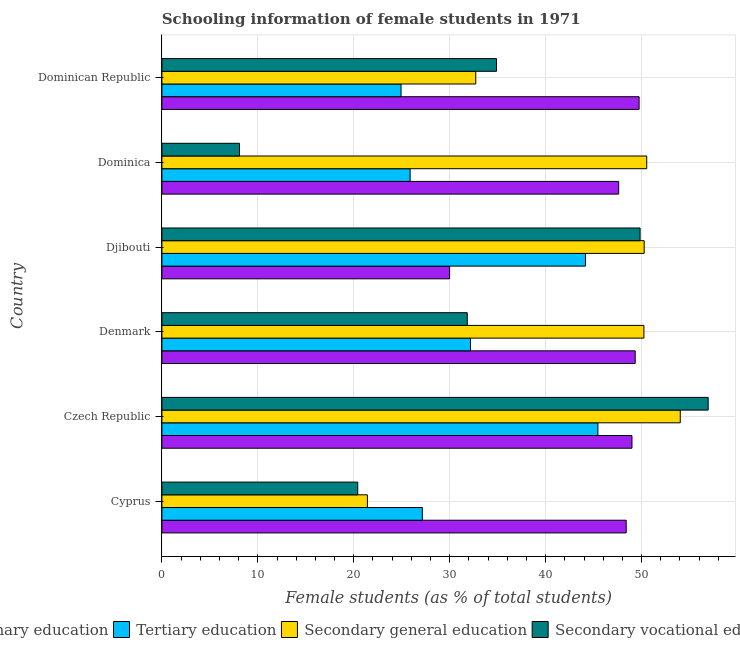How many different coloured bars are there?
Your answer should be compact. 4. Are the number of bars per tick equal to the number of legend labels?
Ensure brevity in your answer.  Yes. What is the label of the 4th group of bars from the top?
Your response must be concise. Denmark. In how many cases, is the number of bars for a given country not equal to the number of legend labels?
Keep it short and to the point. 0. What is the percentage of female students in secondary education in Dominica?
Your response must be concise. 50.54. Across all countries, what is the maximum percentage of female students in secondary vocational education?
Provide a short and direct response. 56.94. Across all countries, what is the minimum percentage of female students in secondary education?
Your response must be concise. 21.42. In which country was the percentage of female students in primary education maximum?
Provide a succinct answer. Dominican Republic. In which country was the percentage of female students in tertiary education minimum?
Provide a short and direct response. Dominican Republic. What is the total percentage of female students in secondary vocational education in the graph?
Ensure brevity in your answer.  202. What is the difference between the percentage of female students in secondary vocational education in Czech Republic and that in Djibouti?
Provide a short and direct response. 7.1. What is the difference between the percentage of female students in secondary vocational education in Cyprus and the percentage of female students in tertiary education in Denmark?
Give a very brief answer. -11.76. What is the average percentage of female students in primary education per country?
Your response must be concise. 45.68. What is the difference between the percentage of female students in tertiary education and percentage of female students in secondary vocational education in Dominica?
Your answer should be compact. 17.79. In how many countries, is the percentage of female students in tertiary education greater than 30 %?
Give a very brief answer. 3. What is the ratio of the percentage of female students in secondary vocational education in Denmark to that in Djibouti?
Offer a very short reply. 0.64. Is the difference between the percentage of female students in secondary education in Czech Republic and Dominica greater than the difference between the percentage of female students in primary education in Czech Republic and Dominica?
Your response must be concise. Yes. What is the difference between the highest and the second highest percentage of female students in tertiary education?
Your answer should be very brief. 1.3. What is the difference between the highest and the lowest percentage of female students in secondary vocational education?
Your answer should be very brief. 48.86. Is it the case that in every country, the sum of the percentage of female students in tertiary education and percentage of female students in secondary vocational education is greater than the sum of percentage of female students in primary education and percentage of female students in secondary education?
Provide a succinct answer. No. What does the 1st bar from the top in Czech Republic represents?
Your answer should be compact. Secondary vocational education. What does the 3rd bar from the bottom in Djibouti represents?
Keep it short and to the point. Secondary general education. Is it the case that in every country, the sum of the percentage of female students in primary education and percentage of female students in tertiary education is greater than the percentage of female students in secondary education?
Keep it short and to the point. Yes. What is the difference between two consecutive major ticks on the X-axis?
Keep it short and to the point. 10. Are the values on the major ticks of X-axis written in scientific E-notation?
Keep it short and to the point. No. Does the graph contain any zero values?
Provide a succinct answer. No. Does the graph contain grids?
Offer a terse response. Yes. How many legend labels are there?
Give a very brief answer. 4. What is the title of the graph?
Your response must be concise. Schooling information of female students in 1971. Does "Agriculture" appear as one of the legend labels in the graph?
Make the answer very short. No. What is the label or title of the X-axis?
Offer a terse response. Female students (as % of total students). What is the label or title of the Y-axis?
Your answer should be very brief. Country. What is the Female students (as % of total students) in Primary education in Cyprus?
Provide a short and direct response. 48.4. What is the Female students (as % of total students) in Tertiary education in Cyprus?
Ensure brevity in your answer.  27.15. What is the Female students (as % of total students) in Secondary general education in Cyprus?
Give a very brief answer. 21.42. What is the Female students (as % of total students) of Secondary vocational education in Cyprus?
Your response must be concise. 20.41. What is the Female students (as % of total students) in Primary education in Czech Republic?
Your answer should be compact. 49. What is the Female students (as % of total students) of Tertiary education in Czech Republic?
Your answer should be compact. 45.45. What is the Female students (as % of total students) in Secondary general education in Czech Republic?
Your answer should be very brief. 54.03. What is the Female students (as % of total students) of Secondary vocational education in Czech Republic?
Offer a terse response. 56.94. What is the Female students (as % of total students) in Primary education in Denmark?
Offer a terse response. 49.33. What is the Female students (as % of total students) in Tertiary education in Denmark?
Your response must be concise. 32.17. What is the Female students (as % of total students) in Secondary general education in Denmark?
Ensure brevity in your answer.  50.24. What is the Female students (as % of total students) in Secondary vocational education in Denmark?
Your answer should be compact. 31.83. What is the Female students (as % of total students) of Primary education in Djibouti?
Your response must be concise. 29.99. What is the Female students (as % of total students) of Tertiary education in Djibouti?
Provide a short and direct response. 44.15. What is the Female students (as % of total students) of Secondary general education in Djibouti?
Make the answer very short. 50.27. What is the Female students (as % of total students) in Secondary vocational education in Djibouti?
Keep it short and to the point. 49.85. What is the Female students (as % of total students) of Primary education in Dominica?
Your answer should be very brief. 47.61. What is the Female students (as % of total students) in Tertiary education in Dominica?
Offer a terse response. 25.87. What is the Female students (as % of total students) in Secondary general education in Dominica?
Your response must be concise. 50.54. What is the Female students (as % of total students) of Secondary vocational education in Dominica?
Offer a very short reply. 8.09. What is the Female students (as % of total students) in Primary education in Dominican Republic?
Keep it short and to the point. 49.74. What is the Female students (as % of total students) of Tertiary education in Dominican Republic?
Provide a succinct answer. 24.93. What is the Female students (as % of total students) of Secondary general education in Dominican Republic?
Offer a terse response. 32.72. What is the Female students (as % of total students) in Secondary vocational education in Dominican Republic?
Give a very brief answer. 34.88. Across all countries, what is the maximum Female students (as % of total students) of Primary education?
Provide a succinct answer. 49.74. Across all countries, what is the maximum Female students (as % of total students) of Tertiary education?
Your answer should be compact. 45.45. Across all countries, what is the maximum Female students (as % of total students) of Secondary general education?
Provide a short and direct response. 54.03. Across all countries, what is the maximum Female students (as % of total students) in Secondary vocational education?
Provide a succinct answer. 56.94. Across all countries, what is the minimum Female students (as % of total students) of Primary education?
Ensure brevity in your answer.  29.99. Across all countries, what is the minimum Female students (as % of total students) in Tertiary education?
Make the answer very short. 24.93. Across all countries, what is the minimum Female students (as % of total students) in Secondary general education?
Your answer should be very brief. 21.42. Across all countries, what is the minimum Female students (as % of total students) of Secondary vocational education?
Make the answer very short. 8.09. What is the total Female students (as % of total students) of Primary education in the graph?
Your answer should be compact. 274.08. What is the total Female students (as % of total students) in Tertiary education in the graph?
Keep it short and to the point. 199.72. What is the total Female students (as % of total students) in Secondary general education in the graph?
Give a very brief answer. 259.22. What is the total Female students (as % of total students) of Secondary vocational education in the graph?
Give a very brief answer. 202. What is the difference between the Female students (as % of total students) in Primary education in Cyprus and that in Czech Republic?
Your answer should be very brief. -0.6. What is the difference between the Female students (as % of total students) of Tertiary education in Cyprus and that in Czech Republic?
Ensure brevity in your answer.  -18.3. What is the difference between the Female students (as % of total students) in Secondary general education in Cyprus and that in Czech Republic?
Offer a very short reply. -32.61. What is the difference between the Female students (as % of total students) in Secondary vocational education in Cyprus and that in Czech Republic?
Give a very brief answer. -36.53. What is the difference between the Female students (as % of total students) of Primary education in Cyprus and that in Denmark?
Your answer should be compact. -0.94. What is the difference between the Female students (as % of total students) of Tertiary education in Cyprus and that in Denmark?
Make the answer very short. -5.02. What is the difference between the Female students (as % of total students) in Secondary general education in Cyprus and that in Denmark?
Give a very brief answer. -28.82. What is the difference between the Female students (as % of total students) of Secondary vocational education in Cyprus and that in Denmark?
Offer a terse response. -11.42. What is the difference between the Female students (as % of total students) of Primary education in Cyprus and that in Djibouti?
Provide a short and direct response. 18.41. What is the difference between the Female students (as % of total students) in Tertiary education in Cyprus and that in Djibouti?
Make the answer very short. -17. What is the difference between the Female students (as % of total students) of Secondary general education in Cyprus and that in Djibouti?
Keep it short and to the point. -28.85. What is the difference between the Female students (as % of total students) of Secondary vocational education in Cyprus and that in Djibouti?
Provide a short and direct response. -29.43. What is the difference between the Female students (as % of total students) in Primary education in Cyprus and that in Dominica?
Keep it short and to the point. 0.78. What is the difference between the Female students (as % of total students) in Tertiary education in Cyprus and that in Dominica?
Your answer should be compact. 1.28. What is the difference between the Female students (as % of total students) of Secondary general education in Cyprus and that in Dominica?
Keep it short and to the point. -29.12. What is the difference between the Female students (as % of total students) in Secondary vocational education in Cyprus and that in Dominica?
Offer a very short reply. 12.33. What is the difference between the Female students (as % of total students) in Primary education in Cyprus and that in Dominican Republic?
Your answer should be compact. -1.35. What is the difference between the Female students (as % of total students) of Tertiary education in Cyprus and that in Dominican Republic?
Keep it short and to the point. 2.22. What is the difference between the Female students (as % of total students) of Secondary general education in Cyprus and that in Dominican Republic?
Offer a terse response. -11.3. What is the difference between the Female students (as % of total students) in Secondary vocational education in Cyprus and that in Dominican Republic?
Provide a short and direct response. -14.46. What is the difference between the Female students (as % of total students) of Primary education in Czech Republic and that in Denmark?
Provide a succinct answer. -0.33. What is the difference between the Female students (as % of total students) in Tertiary education in Czech Republic and that in Denmark?
Provide a short and direct response. 13.28. What is the difference between the Female students (as % of total students) in Secondary general education in Czech Republic and that in Denmark?
Offer a very short reply. 3.79. What is the difference between the Female students (as % of total students) in Secondary vocational education in Czech Republic and that in Denmark?
Provide a succinct answer. 25.11. What is the difference between the Female students (as % of total students) of Primary education in Czech Republic and that in Djibouti?
Give a very brief answer. 19.01. What is the difference between the Female students (as % of total students) in Tertiary education in Czech Republic and that in Djibouti?
Keep it short and to the point. 1.3. What is the difference between the Female students (as % of total students) in Secondary general education in Czech Republic and that in Djibouti?
Offer a terse response. 3.76. What is the difference between the Female students (as % of total students) in Secondary vocational education in Czech Republic and that in Djibouti?
Offer a very short reply. 7.1. What is the difference between the Female students (as % of total students) of Primary education in Czech Republic and that in Dominica?
Offer a terse response. 1.39. What is the difference between the Female students (as % of total students) of Tertiary education in Czech Republic and that in Dominica?
Provide a short and direct response. 19.58. What is the difference between the Female students (as % of total students) of Secondary general education in Czech Republic and that in Dominica?
Give a very brief answer. 3.5. What is the difference between the Female students (as % of total students) of Secondary vocational education in Czech Republic and that in Dominica?
Ensure brevity in your answer.  48.85. What is the difference between the Female students (as % of total students) in Primary education in Czech Republic and that in Dominican Republic?
Provide a short and direct response. -0.74. What is the difference between the Female students (as % of total students) in Tertiary education in Czech Republic and that in Dominican Republic?
Keep it short and to the point. 20.52. What is the difference between the Female students (as % of total students) of Secondary general education in Czech Republic and that in Dominican Republic?
Your response must be concise. 21.32. What is the difference between the Female students (as % of total students) of Secondary vocational education in Czech Republic and that in Dominican Republic?
Your answer should be compact. 22.06. What is the difference between the Female students (as % of total students) of Primary education in Denmark and that in Djibouti?
Ensure brevity in your answer.  19.34. What is the difference between the Female students (as % of total students) in Tertiary education in Denmark and that in Djibouti?
Your answer should be compact. -11.98. What is the difference between the Female students (as % of total students) of Secondary general education in Denmark and that in Djibouti?
Provide a short and direct response. -0.03. What is the difference between the Female students (as % of total students) of Secondary vocational education in Denmark and that in Djibouti?
Provide a short and direct response. -18.02. What is the difference between the Female students (as % of total students) in Primary education in Denmark and that in Dominica?
Your answer should be very brief. 1.72. What is the difference between the Female students (as % of total students) in Tertiary education in Denmark and that in Dominica?
Provide a short and direct response. 6.3. What is the difference between the Female students (as % of total students) in Secondary general education in Denmark and that in Dominica?
Make the answer very short. -0.29. What is the difference between the Female students (as % of total students) in Secondary vocational education in Denmark and that in Dominica?
Your answer should be very brief. 23.74. What is the difference between the Female students (as % of total students) in Primary education in Denmark and that in Dominican Republic?
Your answer should be compact. -0.41. What is the difference between the Female students (as % of total students) in Tertiary education in Denmark and that in Dominican Republic?
Offer a very short reply. 7.24. What is the difference between the Female students (as % of total students) in Secondary general education in Denmark and that in Dominican Republic?
Keep it short and to the point. 17.53. What is the difference between the Female students (as % of total students) in Secondary vocational education in Denmark and that in Dominican Republic?
Keep it short and to the point. -3.05. What is the difference between the Female students (as % of total students) in Primary education in Djibouti and that in Dominica?
Make the answer very short. -17.62. What is the difference between the Female students (as % of total students) in Tertiary education in Djibouti and that in Dominica?
Offer a terse response. 18.28. What is the difference between the Female students (as % of total students) of Secondary general education in Djibouti and that in Dominica?
Your answer should be compact. -0.26. What is the difference between the Female students (as % of total students) of Secondary vocational education in Djibouti and that in Dominica?
Make the answer very short. 41.76. What is the difference between the Female students (as % of total students) of Primary education in Djibouti and that in Dominican Republic?
Keep it short and to the point. -19.75. What is the difference between the Female students (as % of total students) in Tertiary education in Djibouti and that in Dominican Republic?
Offer a very short reply. 19.22. What is the difference between the Female students (as % of total students) in Secondary general education in Djibouti and that in Dominican Republic?
Ensure brevity in your answer.  17.55. What is the difference between the Female students (as % of total students) of Secondary vocational education in Djibouti and that in Dominican Republic?
Provide a succinct answer. 14.97. What is the difference between the Female students (as % of total students) of Primary education in Dominica and that in Dominican Republic?
Your answer should be compact. -2.13. What is the difference between the Female students (as % of total students) in Tertiary education in Dominica and that in Dominican Republic?
Provide a succinct answer. 0.95. What is the difference between the Female students (as % of total students) of Secondary general education in Dominica and that in Dominican Republic?
Provide a succinct answer. 17.82. What is the difference between the Female students (as % of total students) of Secondary vocational education in Dominica and that in Dominican Republic?
Offer a terse response. -26.79. What is the difference between the Female students (as % of total students) in Primary education in Cyprus and the Female students (as % of total students) in Tertiary education in Czech Republic?
Provide a short and direct response. 2.95. What is the difference between the Female students (as % of total students) in Primary education in Cyprus and the Female students (as % of total students) in Secondary general education in Czech Republic?
Offer a terse response. -5.64. What is the difference between the Female students (as % of total students) of Primary education in Cyprus and the Female students (as % of total students) of Secondary vocational education in Czech Republic?
Your answer should be compact. -8.55. What is the difference between the Female students (as % of total students) of Tertiary education in Cyprus and the Female students (as % of total students) of Secondary general education in Czech Republic?
Your response must be concise. -26.89. What is the difference between the Female students (as % of total students) in Tertiary education in Cyprus and the Female students (as % of total students) in Secondary vocational education in Czech Republic?
Your response must be concise. -29.8. What is the difference between the Female students (as % of total students) in Secondary general education in Cyprus and the Female students (as % of total students) in Secondary vocational education in Czech Republic?
Make the answer very short. -35.52. What is the difference between the Female students (as % of total students) in Primary education in Cyprus and the Female students (as % of total students) in Tertiary education in Denmark?
Your answer should be very brief. 16.23. What is the difference between the Female students (as % of total students) of Primary education in Cyprus and the Female students (as % of total students) of Secondary general education in Denmark?
Offer a terse response. -1.84. What is the difference between the Female students (as % of total students) in Primary education in Cyprus and the Female students (as % of total students) in Secondary vocational education in Denmark?
Provide a short and direct response. 16.57. What is the difference between the Female students (as % of total students) in Tertiary education in Cyprus and the Female students (as % of total students) in Secondary general education in Denmark?
Your response must be concise. -23.09. What is the difference between the Female students (as % of total students) of Tertiary education in Cyprus and the Female students (as % of total students) of Secondary vocational education in Denmark?
Give a very brief answer. -4.68. What is the difference between the Female students (as % of total students) of Secondary general education in Cyprus and the Female students (as % of total students) of Secondary vocational education in Denmark?
Keep it short and to the point. -10.41. What is the difference between the Female students (as % of total students) in Primary education in Cyprus and the Female students (as % of total students) in Tertiary education in Djibouti?
Provide a short and direct response. 4.25. What is the difference between the Female students (as % of total students) of Primary education in Cyprus and the Female students (as % of total students) of Secondary general education in Djibouti?
Provide a succinct answer. -1.87. What is the difference between the Female students (as % of total students) in Primary education in Cyprus and the Female students (as % of total students) in Secondary vocational education in Djibouti?
Make the answer very short. -1.45. What is the difference between the Female students (as % of total students) in Tertiary education in Cyprus and the Female students (as % of total students) in Secondary general education in Djibouti?
Ensure brevity in your answer.  -23.12. What is the difference between the Female students (as % of total students) of Tertiary education in Cyprus and the Female students (as % of total students) of Secondary vocational education in Djibouti?
Your answer should be compact. -22.7. What is the difference between the Female students (as % of total students) of Secondary general education in Cyprus and the Female students (as % of total students) of Secondary vocational education in Djibouti?
Make the answer very short. -28.43. What is the difference between the Female students (as % of total students) in Primary education in Cyprus and the Female students (as % of total students) in Tertiary education in Dominica?
Ensure brevity in your answer.  22.52. What is the difference between the Female students (as % of total students) of Primary education in Cyprus and the Female students (as % of total students) of Secondary general education in Dominica?
Give a very brief answer. -2.14. What is the difference between the Female students (as % of total students) in Primary education in Cyprus and the Female students (as % of total students) in Secondary vocational education in Dominica?
Provide a short and direct response. 40.31. What is the difference between the Female students (as % of total students) of Tertiary education in Cyprus and the Female students (as % of total students) of Secondary general education in Dominica?
Offer a very short reply. -23.39. What is the difference between the Female students (as % of total students) in Tertiary education in Cyprus and the Female students (as % of total students) in Secondary vocational education in Dominica?
Keep it short and to the point. 19.06. What is the difference between the Female students (as % of total students) of Secondary general education in Cyprus and the Female students (as % of total students) of Secondary vocational education in Dominica?
Keep it short and to the point. 13.33. What is the difference between the Female students (as % of total students) in Primary education in Cyprus and the Female students (as % of total students) in Tertiary education in Dominican Republic?
Provide a succinct answer. 23.47. What is the difference between the Female students (as % of total students) in Primary education in Cyprus and the Female students (as % of total students) in Secondary general education in Dominican Republic?
Your response must be concise. 15.68. What is the difference between the Female students (as % of total students) in Primary education in Cyprus and the Female students (as % of total students) in Secondary vocational education in Dominican Republic?
Keep it short and to the point. 13.52. What is the difference between the Female students (as % of total students) of Tertiary education in Cyprus and the Female students (as % of total students) of Secondary general education in Dominican Republic?
Provide a short and direct response. -5.57. What is the difference between the Female students (as % of total students) in Tertiary education in Cyprus and the Female students (as % of total students) in Secondary vocational education in Dominican Republic?
Your answer should be very brief. -7.73. What is the difference between the Female students (as % of total students) of Secondary general education in Cyprus and the Female students (as % of total students) of Secondary vocational education in Dominican Republic?
Provide a short and direct response. -13.46. What is the difference between the Female students (as % of total students) of Primary education in Czech Republic and the Female students (as % of total students) of Tertiary education in Denmark?
Give a very brief answer. 16.83. What is the difference between the Female students (as % of total students) in Primary education in Czech Republic and the Female students (as % of total students) in Secondary general education in Denmark?
Offer a terse response. -1.24. What is the difference between the Female students (as % of total students) in Primary education in Czech Republic and the Female students (as % of total students) in Secondary vocational education in Denmark?
Your answer should be compact. 17.17. What is the difference between the Female students (as % of total students) in Tertiary education in Czech Republic and the Female students (as % of total students) in Secondary general education in Denmark?
Offer a terse response. -4.79. What is the difference between the Female students (as % of total students) of Tertiary education in Czech Republic and the Female students (as % of total students) of Secondary vocational education in Denmark?
Make the answer very short. 13.62. What is the difference between the Female students (as % of total students) of Secondary general education in Czech Republic and the Female students (as % of total students) of Secondary vocational education in Denmark?
Your answer should be compact. 22.2. What is the difference between the Female students (as % of total students) of Primary education in Czech Republic and the Female students (as % of total students) of Tertiary education in Djibouti?
Your response must be concise. 4.85. What is the difference between the Female students (as % of total students) in Primary education in Czech Republic and the Female students (as % of total students) in Secondary general education in Djibouti?
Offer a very short reply. -1.27. What is the difference between the Female students (as % of total students) of Primary education in Czech Republic and the Female students (as % of total students) of Secondary vocational education in Djibouti?
Give a very brief answer. -0.85. What is the difference between the Female students (as % of total students) of Tertiary education in Czech Republic and the Female students (as % of total students) of Secondary general education in Djibouti?
Your answer should be compact. -4.82. What is the difference between the Female students (as % of total students) in Tertiary education in Czech Republic and the Female students (as % of total students) in Secondary vocational education in Djibouti?
Your answer should be compact. -4.4. What is the difference between the Female students (as % of total students) in Secondary general education in Czech Republic and the Female students (as % of total students) in Secondary vocational education in Djibouti?
Your answer should be compact. 4.19. What is the difference between the Female students (as % of total students) in Primary education in Czech Republic and the Female students (as % of total students) in Tertiary education in Dominica?
Provide a short and direct response. 23.13. What is the difference between the Female students (as % of total students) of Primary education in Czech Republic and the Female students (as % of total students) of Secondary general education in Dominica?
Give a very brief answer. -1.54. What is the difference between the Female students (as % of total students) of Primary education in Czech Republic and the Female students (as % of total students) of Secondary vocational education in Dominica?
Ensure brevity in your answer.  40.91. What is the difference between the Female students (as % of total students) in Tertiary education in Czech Republic and the Female students (as % of total students) in Secondary general education in Dominica?
Your answer should be compact. -5.09. What is the difference between the Female students (as % of total students) of Tertiary education in Czech Republic and the Female students (as % of total students) of Secondary vocational education in Dominica?
Your answer should be compact. 37.36. What is the difference between the Female students (as % of total students) of Secondary general education in Czech Republic and the Female students (as % of total students) of Secondary vocational education in Dominica?
Ensure brevity in your answer.  45.95. What is the difference between the Female students (as % of total students) in Primary education in Czech Republic and the Female students (as % of total students) in Tertiary education in Dominican Republic?
Your answer should be compact. 24.07. What is the difference between the Female students (as % of total students) in Primary education in Czech Republic and the Female students (as % of total students) in Secondary general education in Dominican Republic?
Offer a terse response. 16.28. What is the difference between the Female students (as % of total students) in Primary education in Czech Republic and the Female students (as % of total students) in Secondary vocational education in Dominican Republic?
Your answer should be compact. 14.12. What is the difference between the Female students (as % of total students) of Tertiary education in Czech Republic and the Female students (as % of total students) of Secondary general education in Dominican Republic?
Provide a succinct answer. 12.73. What is the difference between the Female students (as % of total students) of Tertiary education in Czech Republic and the Female students (as % of total students) of Secondary vocational education in Dominican Republic?
Give a very brief answer. 10.57. What is the difference between the Female students (as % of total students) in Secondary general education in Czech Republic and the Female students (as % of total students) in Secondary vocational education in Dominican Republic?
Offer a terse response. 19.16. What is the difference between the Female students (as % of total students) in Primary education in Denmark and the Female students (as % of total students) in Tertiary education in Djibouti?
Provide a succinct answer. 5.18. What is the difference between the Female students (as % of total students) in Primary education in Denmark and the Female students (as % of total students) in Secondary general education in Djibouti?
Provide a short and direct response. -0.94. What is the difference between the Female students (as % of total students) of Primary education in Denmark and the Female students (as % of total students) of Secondary vocational education in Djibouti?
Give a very brief answer. -0.51. What is the difference between the Female students (as % of total students) of Tertiary education in Denmark and the Female students (as % of total students) of Secondary general education in Djibouti?
Your answer should be very brief. -18.1. What is the difference between the Female students (as % of total students) in Tertiary education in Denmark and the Female students (as % of total students) in Secondary vocational education in Djibouti?
Ensure brevity in your answer.  -17.68. What is the difference between the Female students (as % of total students) in Secondary general education in Denmark and the Female students (as % of total students) in Secondary vocational education in Djibouti?
Your answer should be compact. 0.4. What is the difference between the Female students (as % of total students) in Primary education in Denmark and the Female students (as % of total students) in Tertiary education in Dominica?
Keep it short and to the point. 23.46. What is the difference between the Female students (as % of total students) of Primary education in Denmark and the Female students (as % of total students) of Secondary general education in Dominica?
Give a very brief answer. -1.2. What is the difference between the Female students (as % of total students) in Primary education in Denmark and the Female students (as % of total students) in Secondary vocational education in Dominica?
Provide a short and direct response. 41.25. What is the difference between the Female students (as % of total students) of Tertiary education in Denmark and the Female students (as % of total students) of Secondary general education in Dominica?
Offer a terse response. -18.37. What is the difference between the Female students (as % of total students) in Tertiary education in Denmark and the Female students (as % of total students) in Secondary vocational education in Dominica?
Make the answer very short. 24.08. What is the difference between the Female students (as % of total students) in Secondary general education in Denmark and the Female students (as % of total students) in Secondary vocational education in Dominica?
Ensure brevity in your answer.  42.15. What is the difference between the Female students (as % of total students) of Primary education in Denmark and the Female students (as % of total students) of Tertiary education in Dominican Republic?
Give a very brief answer. 24.41. What is the difference between the Female students (as % of total students) in Primary education in Denmark and the Female students (as % of total students) in Secondary general education in Dominican Republic?
Make the answer very short. 16.62. What is the difference between the Female students (as % of total students) of Primary education in Denmark and the Female students (as % of total students) of Secondary vocational education in Dominican Republic?
Offer a very short reply. 14.46. What is the difference between the Female students (as % of total students) of Tertiary education in Denmark and the Female students (as % of total students) of Secondary general education in Dominican Republic?
Offer a terse response. -0.55. What is the difference between the Female students (as % of total students) of Tertiary education in Denmark and the Female students (as % of total students) of Secondary vocational education in Dominican Republic?
Make the answer very short. -2.71. What is the difference between the Female students (as % of total students) in Secondary general education in Denmark and the Female students (as % of total students) in Secondary vocational education in Dominican Republic?
Keep it short and to the point. 15.36. What is the difference between the Female students (as % of total students) in Primary education in Djibouti and the Female students (as % of total students) in Tertiary education in Dominica?
Make the answer very short. 4.12. What is the difference between the Female students (as % of total students) of Primary education in Djibouti and the Female students (as % of total students) of Secondary general education in Dominica?
Make the answer very short. -20.55. What is the difference between the Female students (as % of total students) of Primary education in Djibouti and the Female students (as % of total students) of Secondary vocational education in Dominica?
Your response must be concise. 21.9. What is the difference between the Female students (as % of total students) of Tertiary education in Djibouti and the Female students (as % of total students) of Secondary general education in Dominica?
Provide a succinct answer. -6.39. What is the difference between the Female students (as % of total students) in Tertiary education in Djibouti and the Female students (as % of total students) in Secondary vocational education in Dominica?
Your answer should be very brief. 36.06. What is the difference between the Female students (as % of total students) in Secondary general education in Djibouti and the Female students (as % of total students) in Secondary vocational education in Dominica?
Offer a very short reply. 42.18. What is the difference between the Female students (as % of total students) in Primary education in Djibouti and the Female students (as % of total students) in Tertiary education in Dominican Republic?
Give a very brief answer. 5.06. What is the difference between the Female students (as % of total students) of Primary education in Djibouti and the Female students (as % of total students) of Secondary general education in Dominican Republic?
Your response must be concise. -2.73. What is the difference between the Female students (as % of total students) of Primary education in Djibouti and the Female students (as % of total students) of Secondary vocational education in Dominican Republic?
Provide a succinct answer. -4.89. What is the difference between the Female students (as % of total students) in Tertiary education in Djibouti and the Female students (as % of total students) in Secondary general education in Dominican Republic?
Your response must be concise. 11.43. What is the difference between the Female students (as % of total students) of Tertiary education in Djibouti and the Female students (as % of total students) of Secondary vocational education in Dominican Republic?
Provide a short and direct response. 9.27. What is the difference between the Female students (as % of total students) in Secondary general education in Djibouti and the Female students (as % of total students) in Secondary vocational education in Dominican Republic?
Provide a short and direct response. 15.39. What is the difference between the Female students (as % of total students) in Primary education in Dominica and the Female students (as % of total students) in Tertiary education in Dominican Republic?
Ensure brevity in your answer.  22.69. What is the difference between the Female students (as % of total students) of Primary education in Dominica and the Female students (as % of total students) of Secondary general education in Dominican Republic?
Give a very brief answer. 14.9. What is the difference between the Female students (as % of total students) in Primary education in Dominica and the Female students (as % of total students) in Secondary vocational education in Dominican Republic?
Your answer should be compact. 12.73. What is the difference between the Female students (as % of total students) of Tertiary education in Dominica and the Female students (as % of total students) of Secondary general education in Dominican Republic?
Give a very brief answer. -6.84. What is the difference between the Female students (as % of total students) of Tertiary education in Dominica and the Female students (as % of total students) of Secondary vocational education in Dominican Republic?
Your answer should be very brief. -9.01. What is the difference between the Female students (as % of total students) in Secondary general education in Dominica and the Female students (as % of total students) in Secondary vocational education in Dominican Republic?
Provide a short and direct response. 15.66. What is the average Female students (as % of total students) in Primary education per country?
Your answer should be compact. 45.68. What is the average Female students (as % of total students) in Tertiary education per country?
Offer a very short reply. 33.29. What is the average Female students (as % of total students) of Secondary general education per country?
Offer a terse response. 43.2. What is the average Female students (as % of total students) in Secondary vocational education per country?
Offer a very short reply. 33.67. What is the difference between the Female students (as % of total students) of Primary education and Female students (as % of total students) of Tertiary education in Cyprus?
Offer a terse response. 21.25. What is the difference between the Female students (as % of total students) in Primary education and Female students (as % of total students) in Secondary general education in Cyprus?
Offer a terse response. 26.98. What is the difference between the Female students (as % of total students) of Primary education and Female students (as % of total students) of Secondary vocational education in Cyprus?
Offer a terse response. 27.98. What is the difference between the Female students (as % of total students) of Tertiary education and Female students (as % of total students) of Secondary general education in Cyprus?
Offer a terse response. 5.73. What is the difference between the Female students (as % of total students) in Tertiary education and Female students (as % of total students) in Secondary vocational education in Cyprus?
Ensure brevity in your answer.  6.73. What is the difference between the Female students (as % of total students) of Secondary general education and Female students (as % of total students) of Secondary vocational education in Cyprus?
Give a very brief answer. 1.01. What is the difference between the Female students (as % of total students) of Primary education and Female students (as % of total students) of Tertiary education in Czech Republic?
Ensure brevity in your answer.  3.55. What is the difference between the Female students (as % of total students) of Primary education and Female students (as % of total students) of Secondary general education in Czech Republic?
Your answer should be compact. -5.03. What is the difference between the Female students (as % of total students) of Primary education and Female students (as % of total students) of Secondary vocational education in Czech Republic?
Your answer should be very brief. -7.94. What is the difference between the Female students (as % of total students) in Tertiary education and Female students (as % of total students) in Secondary general education in Czech Republic?
Make the answer very short. -8.59. What is the difference between the Female students (as % of total students) of Tertiary education and Female students (as % of total students) of Secondary vocational education in Czech Republic?
Your answer should be very brief. -11.49. What is the difference between the Female students (as % of total students) in Secondary general education and Female students (as % of total students) in Secondary vocational education in Czech Republic?
Provide a succinct answer. -2.91. What is the difference between the Female students (as % of total students) of Primary education and Female students (as % of total students) of Tertiary education in Denmark?
Make the answer very short. 17.16. What is the difference between the Female students (as % of total students) of Primary education and Female students (as % of total students) of Secondary general education in Denmark?
Give a very brief answer. -0.91. What is the difference between the Female students (as % of total students) in Primary education and Female students (as % of total students) in Secondary vocational education in Denmark?
Keep it short and to the point. 17.5. What is the difference between the Female students (as % of total students) in Tertiary education and Female students (as % of total students) in Secondary general education in Denmark?
Make the answer very short. -18.07. What is the difference between the Female students (as % of total students) in Tertiary education and Female students (as % of total students) in Secondary vocational education in Denmark?
Offer a very short reply. 0.34. What is the difference between the Female students (as % of total students) of Secondary general education and Female students (as % of total students) of Secondary vocational education in Denmark?
Ensure brevity in your answer.  18.41. What is the difference between the Female students (as % of total students) in Primary education and Female students (as % of total students) in Tertiary education in Djibouti?
Give a very brief answer. -14.16. What is the difference between the Female students (as % of total students) of Primary education and Female students (as % of total students) of Secondary general education in Djibouti?
Ensure brevity in your answer.  -20.28. What is the difference between the Female students (as % of total students) of Primary education and Female students (as % of total students) of Secondary vocational education in Djibouti?
Give a very brief answer. -19.86. What is the difference between the Female students (as % of total students) of Tertiary education and Female students (as % of total students) of Secondary general education in Djibouti?
Provide a succinct answer. -6.12. What is the difference between the Female students (as % of total students) of Tertiary education and Female students (as % of total students) of Secondary vocational education in Djibouti?
Offer a very short reply. -5.7. What is the difference between the Female students (as % of total students) in Secondary general education and Female students (as % of total students) in Secondary vocational education in Djibouti?
Give a very brief answer. 0.43. What is the difference between the Female students (as % of total students) in Primary education and Female students (as % of total students) in Tertiary education in Dominica?
Offer a very short reply. 21.74. What is the difference between the Female students (as % of total students) of Primary education and Female students (as % of total students) of Secondary general education in Dominica?
Make the answer very short. -2.92. What is the difference between the Female students (as % of total students) in Primary education and Female students (as % of total students) in Secondary vocational education in Dominica?
Keep it short and to the point. 39.53. What is the difference between the Female students (as % of total students) of Tertiary education and Female students (as % of total students) of Secondary general education in Dominica?
Provide a succinct answer. -24.66. What is the difference between the Female students (as % of total students) of Tertiary education and Female students (as % of total students) of Secondary vocational education in Dominica?
Provide a succinct answer. 17.78. What is the difference between the Female students (as % of total students) in Secondary general education and Female students (as % of total students) in Secondary vocational education in Dominica?
Provide a succinct answer. 42.45. What is the difference between the Female students (as % of total students) of Primary education and Female students (as % of total students) of Tertiary education in Dominican Republic?
Ensure brevity in your answer.  24.82. What is the difference between the Female students (as % of total students) in Primary education and Female students (as % of total students) in Secondary general education in Dominican Republic?
Give a very brief answer. 17.03. What is the difference between the Female students (as % of total students) in Primary education and Female students (as % of total students) in Secondary vocational education in Dominican Republic?
Your answer should be compact. 14.87. What is the difference between the Female students (as % of total students) in Tertiary education and Female students (as % of total students) in Secondary general education in Dominican Republic?
Offer a terse response. -7.79. What is the difference between the Female students (as % of total students) in Tertiary education and Female students (as % of total students) in Secondary vocational education in Dominican Republic?
Your response must be concise. -9.95. What is the difference between the Female students (as % of total students) in Secondary general education and Female students (as % of total students) in Secondary vocational education in Dominican Republic?
Offer a very short reply. -2.16. What is the ratio of the Female students (as % of total students) of Primary education in Cyprus to that in Czech Republic?
Offer a terse response. 0.99. What is the ratio of the Female students (as % of total students) of Tertiary education in Cyprus to that in Czech Republic?
Make the answer very short. 0.6. What is the ratio of the Female students (as % of total students) in Secondary general education in Cyprus to that in Czech Republic?
Offer a very short reply. 0.4. What is the ratio of the Female students (as % of total students) of Secondary vocational education in Cyprus to that in Czech Republic?
Give a very brief answer. 0.36. What is the ratio of the Female students (as % of total students) in Primary education in Cyprus to that in Denmark?
Provide a short and direct response. 0.98. What is the ratio of the Female students (as % of total students) of Tertiary education in Cyprus to that in Denmark?
Make the answer very short. 0.84. What is the ratio of the Female students (as % of total students) in Secondary general education in Cyprus to that in Denmark?
Your answer should be very brief. 0.43. What is the ratio of the Female students (as % of total students) in Secondary vocational education in Cyprus to that in Denmark?
Provide a succinct answer. 0.64. What is the ratio of the Female students (as % of total students) in Primary education in Cyprus to that in Djibouti?
Provide a succinct answer. 1.61. What is the ratio of the Female students (as % of total students) in Tertiary education in Cyprus to that in Djibouti?
Your answer should be compact. 0.61. What is the ratio of the Female students (as % of total students) in Secondary general education in Cyprus to that in Djibouti?
Make the answer very short. 0.43. What is the ratio of the Female students (as % of total students) of Secondary vocational education in Cyprus to that in Djibouti?
Your answer should be compact. 0.41. What is the ratio of the Female students (as % of total students) in Primary education in Cyprus to that in Dominica?
Keep it short and to the point. 1.02. What is the ratio of the Female students (as % of total students) of Tertiary education in Cyprus to that in Dominica?
Your answer should be compact. 1.05. What is the ratio of the Female students (as % of total students) of Secondary general education in Cyprus to that in Dominica?
Offer a very short reply. 0.42. What is the ratio of the Female students (as % of total students) in Secondary vocational education in Cyprus to that in Dominica?
Make the answer very short. 2.52. What is the ratio of the Female students (as % of total students) of Primary education in Cyprus to that in Dominican Republic?
Your answer should be compact. 0.97. What is the ratio of the Female students (as % of total students) in Tertiary education in Cyprus to that in Dominican Republic?
Your answer should be compact. 1.09. What is the ratio of the Female students (as % of total students) in Secondary general education in Cyprus to that in Dominican Republic?
Provide a short and direct response. 0.65. What is the ratio of the Female students (as % of total students) in Secondary vocational education in Cyprus to that in Dominican Republic?
Your answer should be very brief. 0.59. What is the ratio of the Female students (as % of total students) in Primary education in Czech Republic to that in Denmark?
Ensure brevity in your answer.  0.99. What is the ratio of the Female students (as % of total students) of Tertiary education in Czech Republic to that in Denmark?
Your response must be concise. 1.41. What is the ratio of the Female students (as % of total students) of Secondary general education in Czech Republic to that in Denmark?
Your answer should be compact. 1.08. What is the ratio of the Female students (as % of total students) in Secondary vocational education in Czech Republic to that in Denmark?
Offer a very short reply. 1.79. What is the ratio of the Female students (as % of total students) in Primary education in Czech Republic to that in Djibouti?
Give a very brief answer. 1.63. What is the ratio of the Female students (as % of total students) of Tertiary education in Czech Republic to that in Djibouti?
Your answer should be compact. 1.03. What is the ratio of the Female students (as % of total students) of Secondary general education in Czech Republic to that in Djibouti?
Ensure brevity in your answer.  1.07. What is the ratio of the Female students (as % of total students) in Secondary vocational education in Czech Republic to that in Djibouti?
Give a very brief answer. 1.14. What is the ratio of the Female students (as % of total students) of Primary education in Czech Republic to that in Dominica?
Offer a very short reply. 1.03. What is the ratio of the Female students (as % of total students) of Tertiary education in Czech Republic to that in Dominica?
Provide a short and direct response. 1.76. What is the ratio of the Female students (as % of total students) of Secondary general education in Czech Republic to that in Dominica?
Provide a succinct answer. 1.07. What is the ratio of the Female students (as % of total students) in Secondary vocational education in Czech Republic to that in Dominica?
Offer a terse response. 7.04. What is the ratio of the Female students (as % of total students) of Primary education in Czech Republic to that in Dominican Republic?
Offer a terse response. 0.98. What is the ratio of the Female students (as % of total students) of Tertiary education in Czech Republic to that in Dominican Republic?
Make the answer very short. 1.82. What is the ratio of the Female students (as % of total students) of Secondary general education in Czech Republic to that in Dominican Republic?
Your answer should be very brief. 1.65. What is the ratio of the Female students (as % of total students) of Secondary vocational education in Czech Republic to that in Dominican Republic?
Your response must be concise. 1.63. What is the ratio of the Female students (as % of total students) of Primary education in Denmark to that in Djibouti?
Offer a very short reply. 1.65. What is the ratio of the Female students (as % of total students) of Tertiary education in Denmark to that in Djibouti?
Make the answer very short. 0.73. What is the ratio of the Female students (as % of total students) in Secondary general education in Denmark to that in Djibouti?
Ensure brevity in your answer.  1. What is the ratio of the Female students (as % of total students) in Secondary vocational education in Denmark to that in Djibouti?
Make the answer very short. 0.64. What is the ratio of the Female students (as % of total students) in Primary education in Denmark to that in Dominica?
Ensure brevity in your answer.  1.04. What is the ratio of the Female students (as % of total students) in Tertiary education in Denmark to that in Dominica?
Your answer should be compact. 1.24. What is the ratio of the Female students (as % of total students) of Secondary vocational education in Denmark to that in Dominica?
Ensure brevity in your answer.  3.94. What is the ratio of the Female students (as % of total students) of Primary education in Denmark to that in Dominican Republic?
Keep it short and to the point. 0.99. What is the ratio of the Female students (as % of total students) of Tertiary education in Denmark to that in Dominican Republic?
Keep it short and to the point. 1.29. What is the ratio of the Female students (as % of total students) in Secondary general education in Denmark to that in Dominican Republic?
Give a very brief answer. 1.54. What is the ratio of the Female students (as % of total students) of Secondary vocational education in Denmark to that in Dominican Republic?
Offer a very short reply. 0.91. What is the ratio of the Female students (as % of total students) in Primary education in Djibouti to that in Dominica?
Your response must be concise. 0.63. What is the ratio of the Female students (as % of total students) of Tertiary education in Djibouti to that in Dominica?
Provide a short and direct response. 1.71. What is the ratio of the Female students (as % of total students) of Secondary general education in Djibouti to that in Dominica?
Offer a terse response. 0.99. What is the ratio of the Female students (as % of total students) in Secondary vocational education in Djibouti to that in Dominica?
Your response must be concise. 6.16. What is the ratio of the Female students (as % of total students) in Primary education in Djibouti to that in Dominican Republic?
Offer a terse response. 0.6. What is the ratio of the Female students (as % of total students) of Tertiary education in Djibouti to that in Dominican Republic?
Ensure brevity in your answer.  1.77. What is the ratio of the Female students (as % of total students) of Secondary general education in Djibouti to that in Dominican Republic?
Make the answer very short. 1.54. What is the ratio of the Female students (as % of total students) in Secondary vocational education in Djibouti to that in Dominican Republic?
Your response must be concise. 1.43. What is the ratio of the Female students (as % of total students) in Primary education in Dominica to that in Dominican Republic?
Your answer should be compact. 0.96. What is the ratio of the Female students (as % of total students) of Tertiary education in Dominica to that in Dominican Republic?
Your answer should be compact. 1.04. What is the ratio of the Female students (as % of total students) of Secondary general education in Dominica to that in Dominican Republic?
Your answer should be very brief. 1.54. What is the ratio of the Female students (as % of total students) in Secondary vocational education in Dominica to that in Dominican Republic?
Make the answer very short. 0.23. What is the difference between the highest and the second highest Female students (as % of total students) of Primary education?
Make the answer very short. 0.41. What is the difference between the highest and the second highest Female students (as % of total students) in Tertiary education?
Your response must be concise. 1.3. What is the difference between the highest and the second highest Female students (as % of total students) of Secondary general education?
Keep it short and to the point. 3.5. What is the difference between the highest and the second highest Female students (as % of total students) in Secondary vocational education?
Your answer should be very brief. 7.1. What is the difference between the highest and the lowest Female students (as % of total students) in Primary education?
Give a very brief answer. 19.75. What is the difference between the highest and the lowest Female students (as % of total students) of Tertiary education?
Offer a very short reply. 20.52. What is the difference between the highest and the lowest Female students (as % of total students) of Secondary general education?
Provide a succinct answer. 32.61. What is the difference between the highest and the lowest Female students (as % of total students) in Secondary vocational education?
Offer a very short reply. 48.85. 